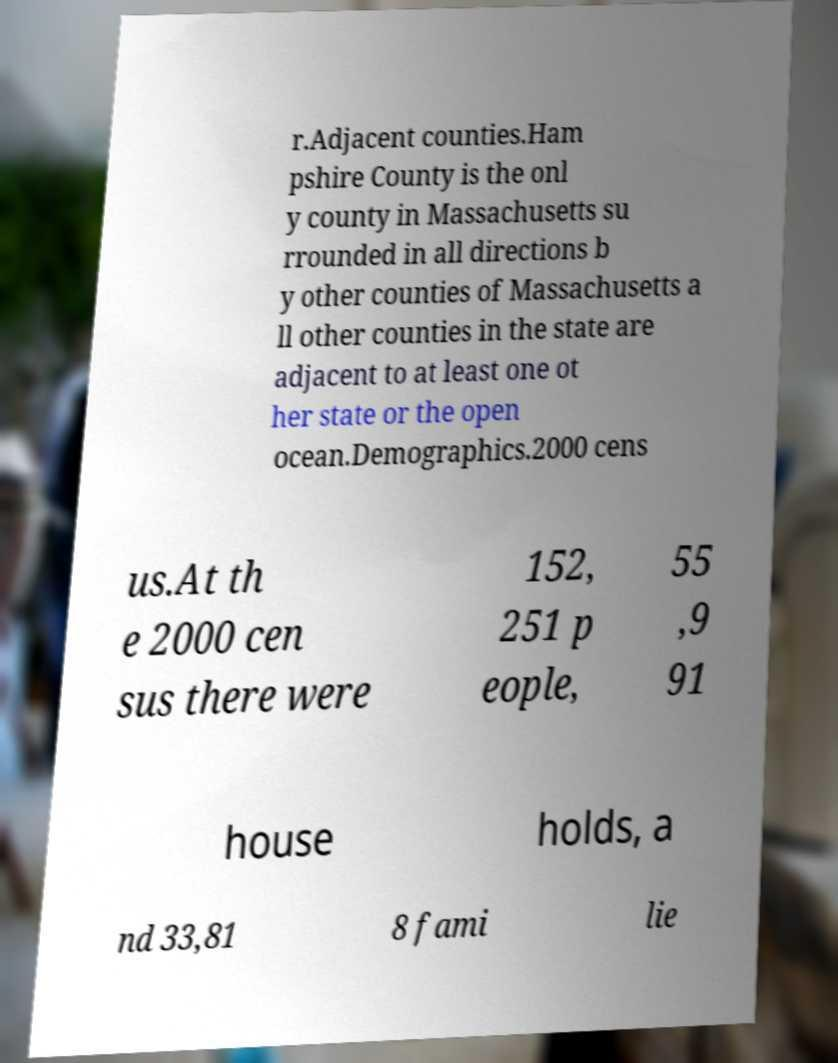I need the written content from this picture converted into text. Can you do that? r.Adjacent counties.Ham pshire County is the onl y county in Massachusetts su rrounded in all directions b y other counties of Massachusetts a ll other counties in the state are adjacent to at least one ot her state or the open ocean.Demographics.2000 cens us.At th e 2000 cen sus there were 152, 251 p eople, 55 ,9 91 house holds, a nd 33,81 8 fami lie 